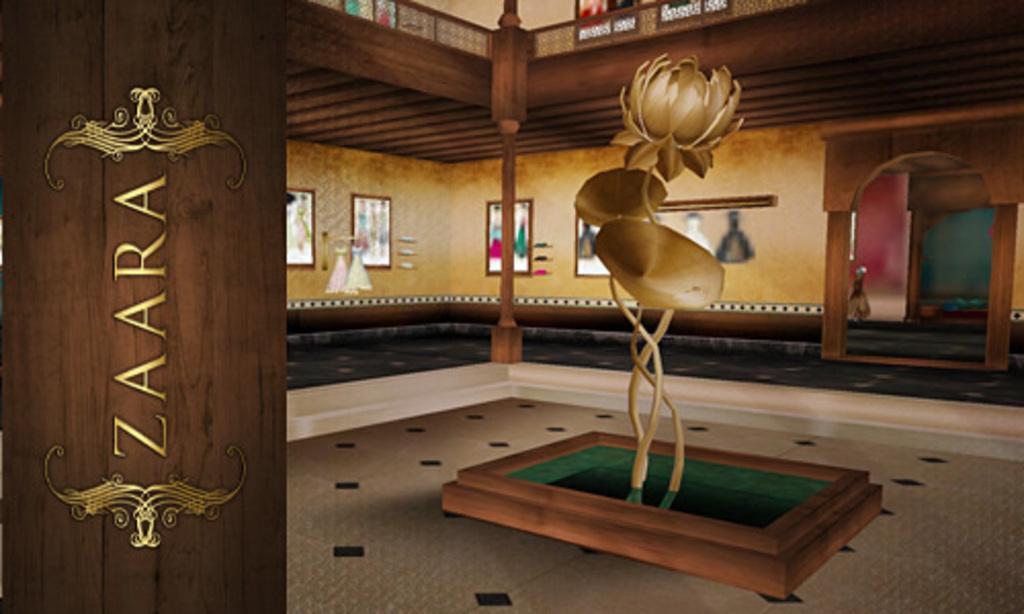In one or two sentences, can you explain what this image depicts? In this image we can see the animated inside of a house. There is some text at the left side of the image. There are many objects in the image. There are few photos on the wall of the houses. 